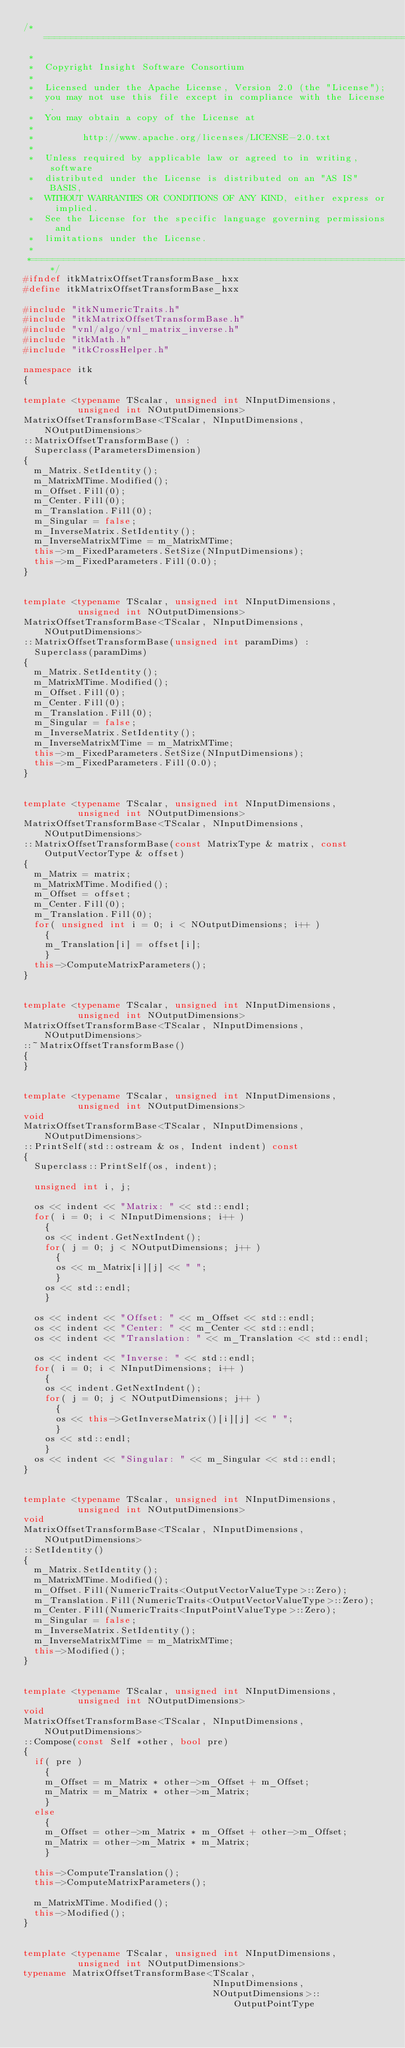Convert code to text. <code><loc_0><loc_0><loc_500><loc_500><_C++_>/*=========================================================================
 *
 *  Copyright Insight Software Consortium
 *
 *  Licensed under the Apache License, Version 2.0 (the "License");
 *  you may not use this file except in compliance with the License.
 *  You may obtain a copy of the License at
 *
 *         http://www.apache.org/licenses/LICENSE-2.0.txt
 *
 *  Unless required by applicable law or agreed to in writing, software
 *  distributed under the License is distributed on an "AS IS" BASIS,
 *  WITHOUT WARRANTIES OR CONDITIONS OF ANY KIND, either express or implied.
 *  See the License for the specific language governing permissions and
 *  limitations under the License.
 *
 *=========================================================================*/
#ifndef itkMatrixOffsetTransformBase_hxx
#define itkMatrixOffsetTransformBase_hxx

#include "itkNumericTraits.h"
#include "itkMatrixOffsetTransformBase.h"
#include "vnl/algo/vnl_matrix_inverse.h"
#include "itkMath.h"
#include "itkCrossHelper.h"

namespace itk
{

template <typename TScalar, unsigned int NInputDimensions,
          unsigned int NOutputDimensions>
MatrixOffsetTransformBase<TScalar, NInputDimensions, NOutputDimensions>
::MatrixOffsetTransformBase() :
  Superclass(ParametersDimension)
{
  m_Matrix.SetIdentity();
  m_MatrixMTime.Modified();
  m_Offset.Fill(0);
  m_Center.Fill(0);
  m_Translation.Fill(0);
  m_Singular = false;
  m_InverseMatrix.SetIdentity();
  m_InverseMatrixMTime = m_MatrixMTime;
  this->m_FixedParameters.SetSize(NInputDimensions);
  this->m_FixedParameters.Fill(0.0);
}


template <typename TScalar, unsigned int NInputDimensions,
          unsigned int NOutputDimensions>
MatrixOffsetTransformBase<TScalar, NInputDimensions, NOutputDimensions>
::MatrixOffsetTransformBase(unsigned int paramDims) :
  Superclass(paramDims)
{
  m_Matrix.SetIdentity();
  m_MatrixMTime.Modified();
  m_Offset.Fill(0);
  m_Center.Fill(0);
  m_Translation.Fill(0);
  m_Singular = false;
  m_InverseMatrix.SetIdentity();
  m_InverseMatrixMTime = m_MatrixMTime;
  this->m_FixedParameters.SetSize(NInputDimensions);
  this->m_FixedParameters.Fill(0.0);
}


template <typename TScalar, unsigned int NInputDimensions,
          unsigned int NOutputDimensions>
MatrixOffsetTransformBase<TScalar, NInputDimensions, NOutputDimensions>
::MatrixOffsetTransformBase(const MatrixType & matrix, const OutputVectorType & offset)
{
  m_Matrix = matrix;
  m_MatrixMTime.Modified();
  m_Offset = offset;
  m_Center.Fill(0);
  m_Translation.Fill(0);
  for( unsigned int i = 0; i < NOutputDimensions; i++ )
    {
    m_Translation[i] = offset[i];
    }
  this->ComputeMatrixParameters();
}


template <typename TScalar, unsigned int NInputDimensions,
          unsigned int NOutputDimensions>
MatrixOffsetTransformBase<TScalar, NInputDimensions, NOutputDimensions>
::~MatrixOffsetTransformBase()
{
}


template <typename TScalar, unsigned int NInputDimensions,
          unsigned int NOutputDimensions>
void
MatrixOffsetTransformBase<TScalar, NInputDimensions, NOutputDimensions>
::PrintSelf(std::ostream & os, Indent indent) const
{
  Superclass::PrintSelf(os, indent);

  unsigned int i, j;

  os << indent << "Matrix: " << std::endl;
  for( i = 0; i < NInputDimensions; i++ )
    {
    os << indent.GetNextIndent();
    for( j = 0; j < NOutputDimensions; j++ )
      {
      os << m_Matrix[i][j] << " ";
      }
    os << std::endl;
    }

  os << indent << "Offset: " << m_Offset << std::endl;
  os << indent << "Center: " << m_Center << std::endl;
  os << indent << "Translation: " << m_Translation << std::endl;

  os << indent << "Inverse: " << std::endl;
  for( i = 0; i < NInputDimensions; i++ )
    {
    os << indent.GetNextIndent();
    for( j = 0; j < NOutputDimensions; j++ )
      {
      os << this->GetInverseMatrix()[i][j] << " ";
      }
    os << std::endl;
    }
  os << indent << "Singular: " << m_Singular << std::endl;
}


template <typename TScalar, unsigned int NInputDimensions,
          unsigned int NOutputDimensions>
void
MatrixOffsetTransformBase<TScalar, NInputDimensions, NOutputDimensions>
::SetIdentity()
{
  m_Matrix.SetIdentity();
  m_MatrixMTime.Modified();
  m_Offset.Fill(NumericTraits<OutputVectorValueType>::Zero);
  m_Translation.Fill(NumericTraits<OutputVectorValueType>::Zero);
  m_Center.Fill(NumericTraits<InputPointValueType>::Zero);
  m_Singular = false;
  m_InverseMatrix.SetIdentity();
  m_InverseMatrixMTime = m_MatrixMTime;
  this->Modified();
}


template <typename TScalar, unsigned int NInputDimensions,
          unsigned int NOutputDimensions>
void
MatrixOffsetTransformBase<TScalar, NInputDimensions, NOutputDimensions>
::Compose(const Self *other, bool pre)
{
  if( pre )
    {
    m_Offset = m_Matrix * other->m_Offset + m_Offset;
    m_Matrix = m_Matrix * other->m_Matrix;
    }
  else
    {
    m_Offset = other->m_Matrix * m_Offset + other->m_Offset;
    m_Matrix = other->m_Matrix * m_Matrix;
    }

  this->ComputeTranslation();
  this->ComputeMatrixParameters();

  m_MatrixMTime.Modified();
  this->Modified();
}


template <typename TScalar, unsigned int NInputDimensions,
          unsigned int NOutputDimensions>
typename MatrixOffsetTransformBase<TScalar,
                                   NInputDimensions,
                                   NOutputDimensions>::OutputPointType</code> 